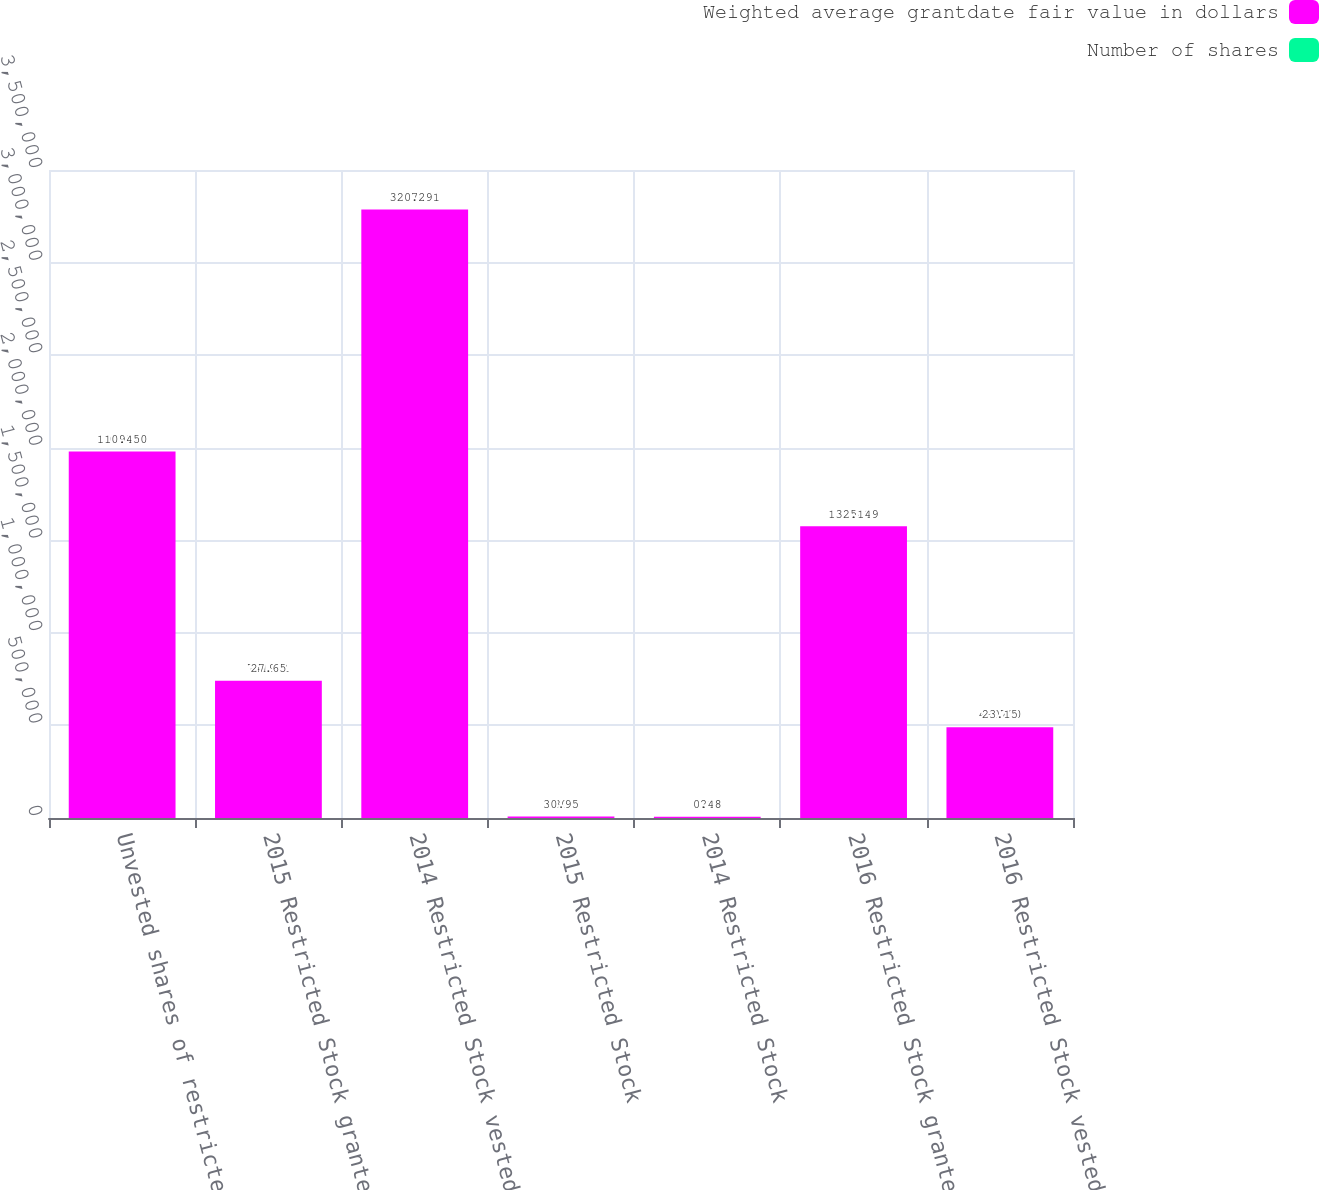Convert chart. <chart><loc_0><loc_0><loc_500><loc_500><stacked_bar_chart><ecel><fcel>Unvested shares of restricted<fcel>2015 Restricted Stock granted<fcel>2014 Restricted Stock vested<fcel>2015 Restricted Stock<fcel>2014 Restricted Stock<fcel>2016 Restricted Stock granted<fcel>2016 Restricted Stock vested<nl><fcel>Weighted average grantdate fair value in dollars<fcel>1.97984e+06<fcel>741931<fcel>3.28709e+06<fcel>7805<fcel>7215<fcel>1.57543e+06<fcel>490700<nl><fcel>Number of shares<fcel>10.45<fcel>27.65<fcel>0.2<fcel>30.95<fcel>0.48<fcel>32.14<fcel>23.15<nl></chart> 